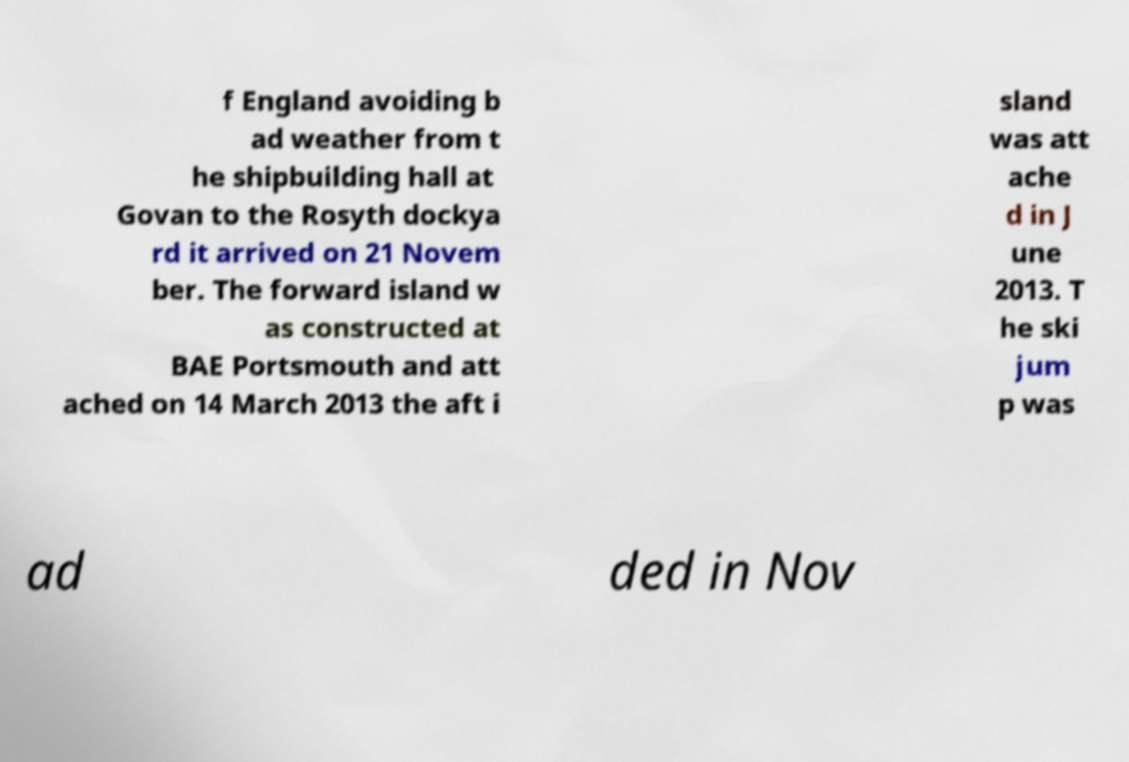Can you accurately transcribe the text from the provided image for me? f England avoiding b ad weather from t he shipbuilding hall at Govan to the Rosyth dockya rd it arrived on 21 Novem ber. The forward island w as constructed at BAE Portsmouth and att ached on 14 March 2013 the aft i sland was att ache d in J une 2013. T he ski jum p was ad ded in Nov 